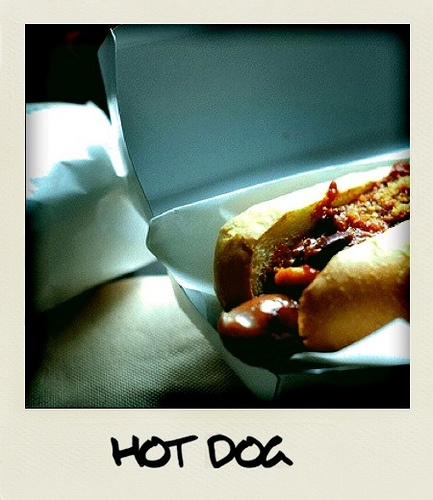Describe the objects in this image and their specific colors. I can see a hot dog in ivory, black, maroon, and olive tones in this image. 